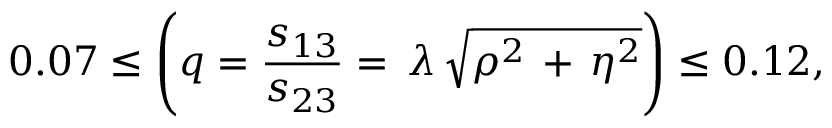Convert formula to latex. <formula><loc_0><loc_0><loc_500><loc_500>0 . 0 7 \leq { \left ( { q = { \frac { s _ { 1 3 } } { s _ { 2 3 } } } } = \, \lambda \, \sqrt { \rho ^ { 2 } \, + \, \eta ^ { 2 } } \right ) } \leq 0 . 1 2 ,</formula> 